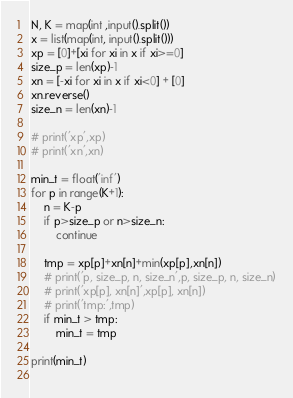Convert code to text. <code><loc_0><loc_0><loc_500><loc_500><_Python_>N, K = map(int ,input().split())
x = list(map(int, input().split()))
xp = [0]+[xi for xi in x if xi>=0]
size_p = len(xp)-1
xn = [-xi for xi in x if xi<0] + [0]
xn.reverse()
size_n = len(xn)-1

# print('xp',xp)
# print('xn',xn)

min_t = float('inf')
for p in range(K+1):
	n = K-p
	if p>size_p or n>size_n:
		continue
	
	tmp = xp[p]+xn[n]+min(xp[p],xn[n])
	# print('p, size_p, n, size_n',p, size_p, n, size_n)
	# print('xp[p], xn[n]',xp[p], xn[n])
	# print('tmp:',tmp)
	if min_t > tmp:
		min_t = tmp

print(min_t)
	

</code> 